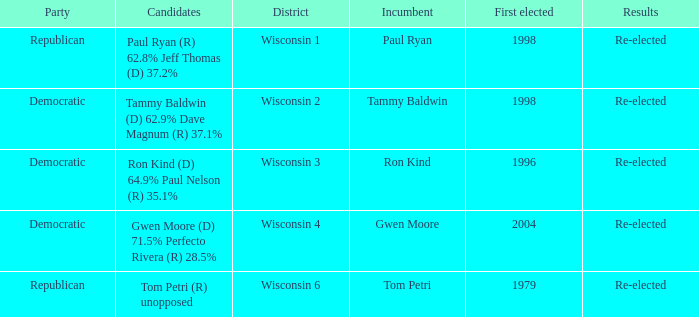What district first elected a Democratic incumbent in 1998? Wisconsin 2. 